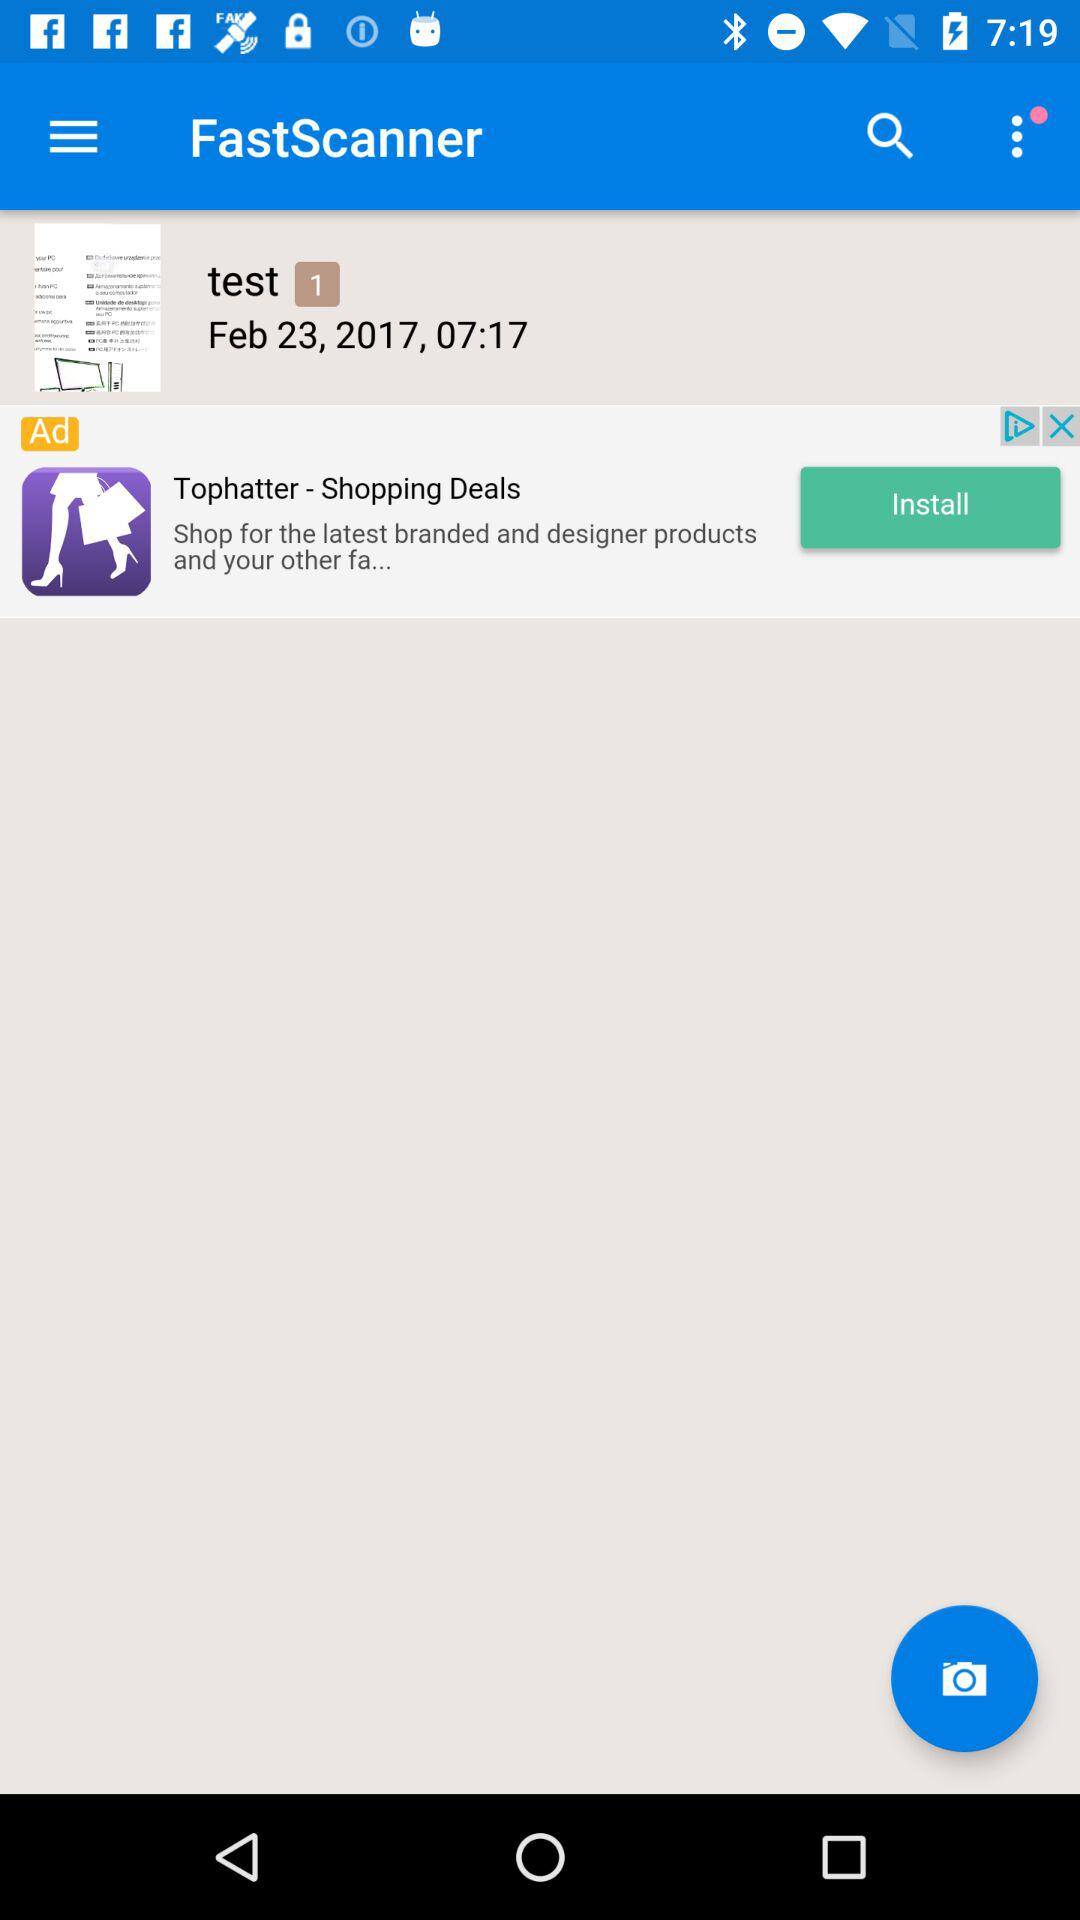What is the application name? The application name is "FastScanner". 